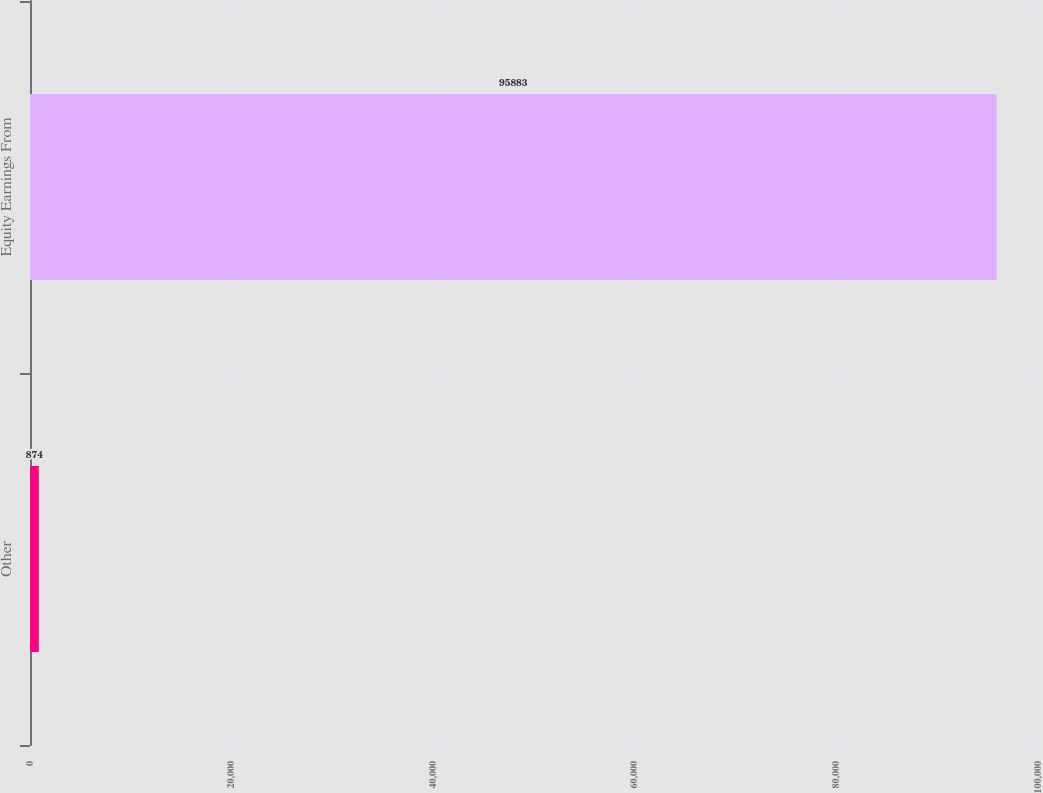Convert chart to OTSL. <chart><loc_0><loc_0><loc_500><loc_500><bar_chart><fcel>Other<fcel>Equity Earnings From<nl><fcel>874<fcel>95883<nl></chart> 